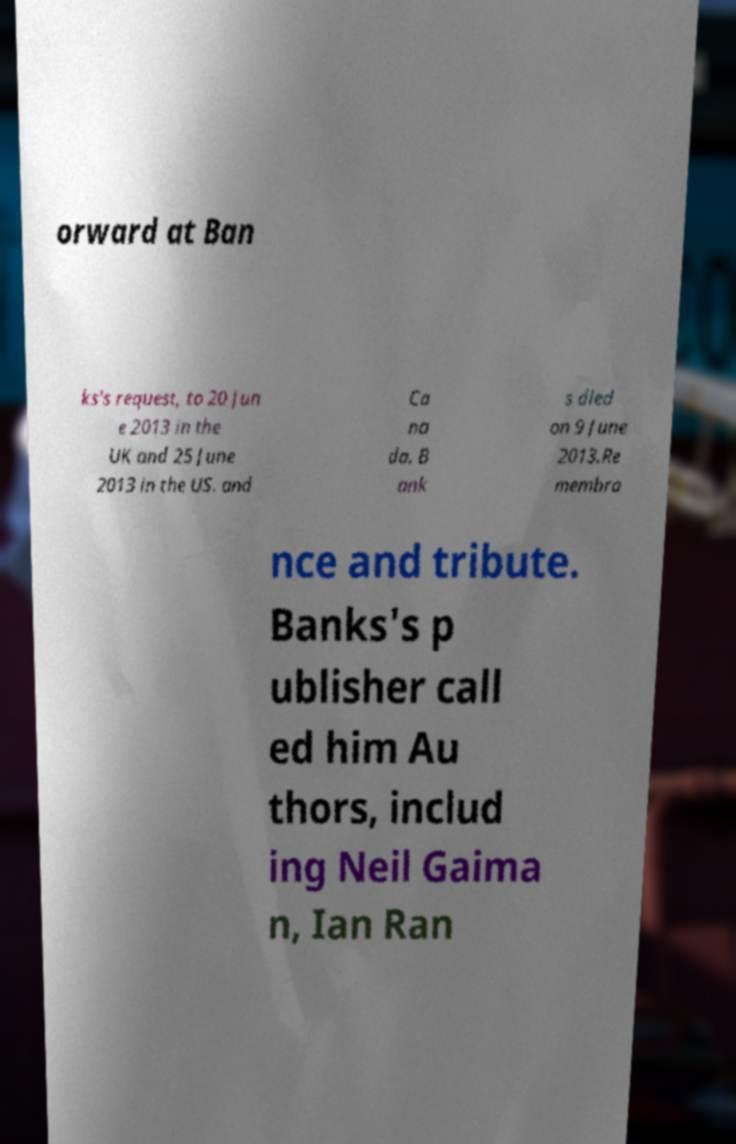Could you assist in decoding the text presented in this image and type it out clearly? orward at Ban ks's request, to 20 Jun e 2013 in the UK and 25 June 2013 in the US. and Ca na da. B ank s died on 9 June 2013.Re membra nce and tribute. Banks's p ublisher call ed him Au thors, includ ing Neil Gaima n, Ian Ran 